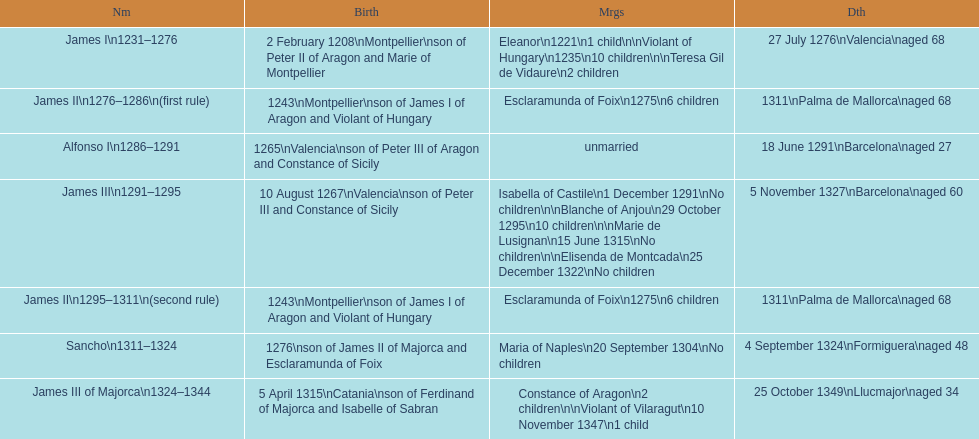How many of these monarchs died before the age of 65? 4. 